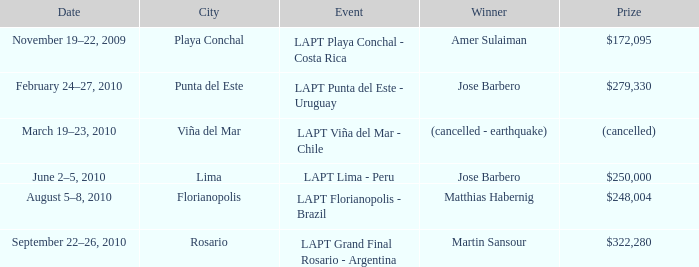What is the date amer sulaiman won? November 19–22, 2009. 